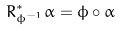Convert formula to latex. <formula><loc_0><loc_0><loc_500><loc_500>R _ { \phi ^ { - 1 } } ^ { * } \alpha = \phi \circ \alpha</formula> 